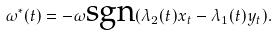Convert formula to latex. <formula><loc_0><loc_0><loc_500><loc_500>\omega ^ { * } ( t ) = - \omega \text {sgn} ( \lambda _ { 2 } ( t ) x _ { t } - \lambda _ { 1 } ( t ) y _ { t } ) .</formula> 